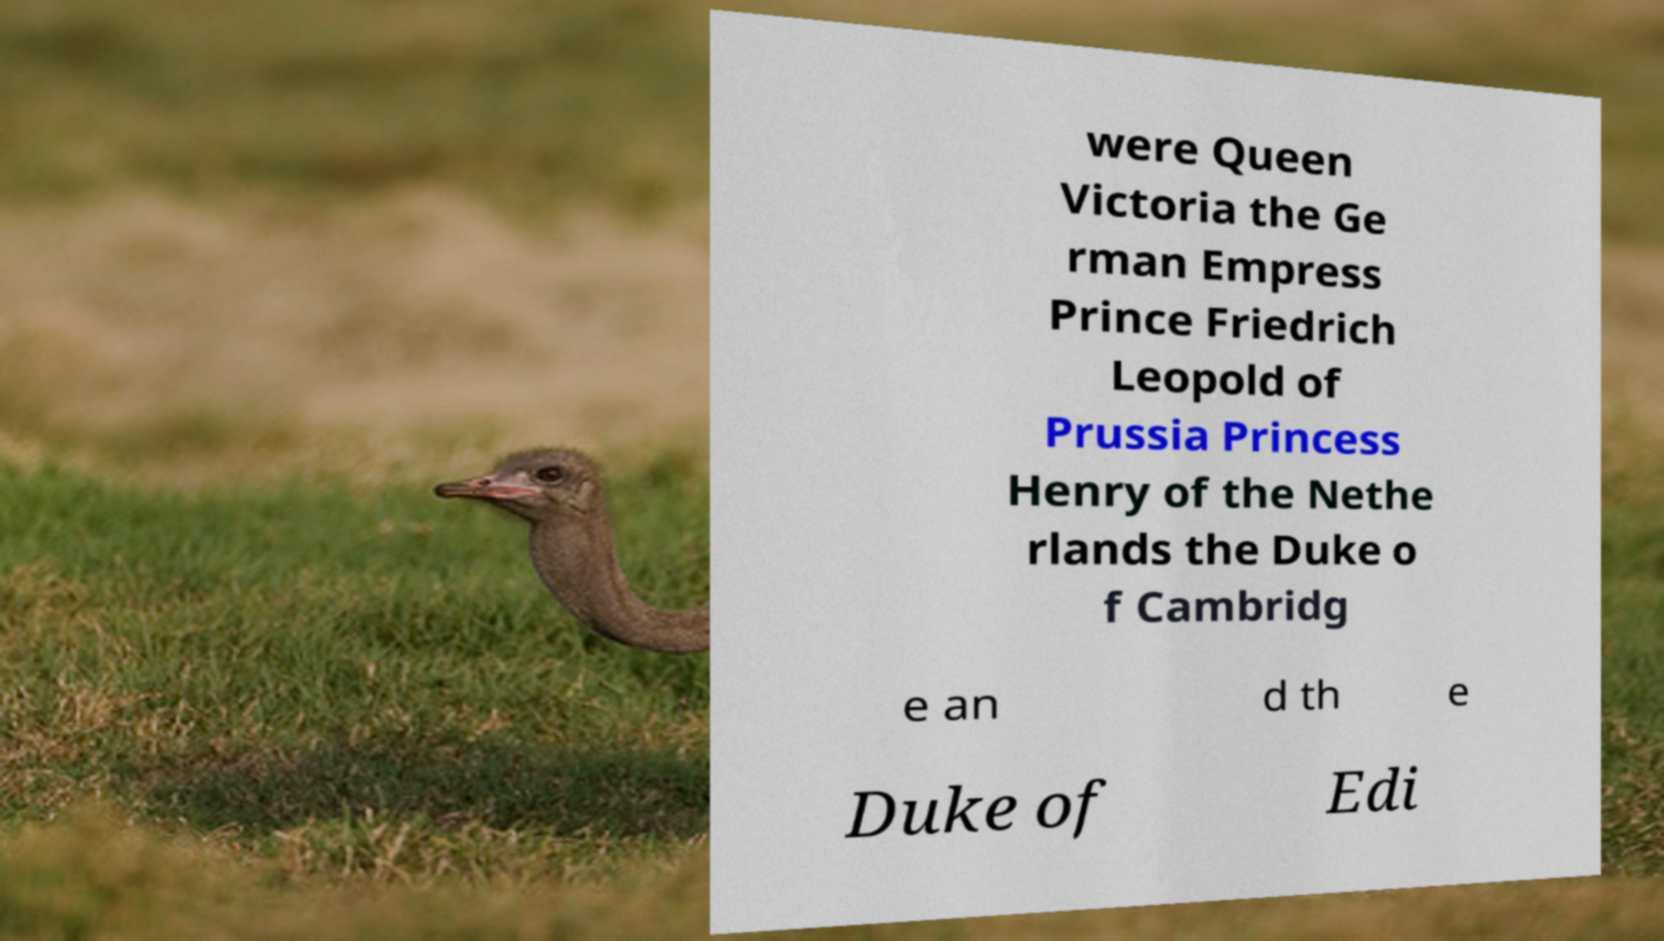For documentation purposes, I need the text within this image transcribed. Could you provide that? were Queen Victoria the Ge rman Empress Prince Friedrich Leopold of Prussia Princess Henry of the Nethe rlands the Duke o f Cambridg e an d th e Duke of Edi 